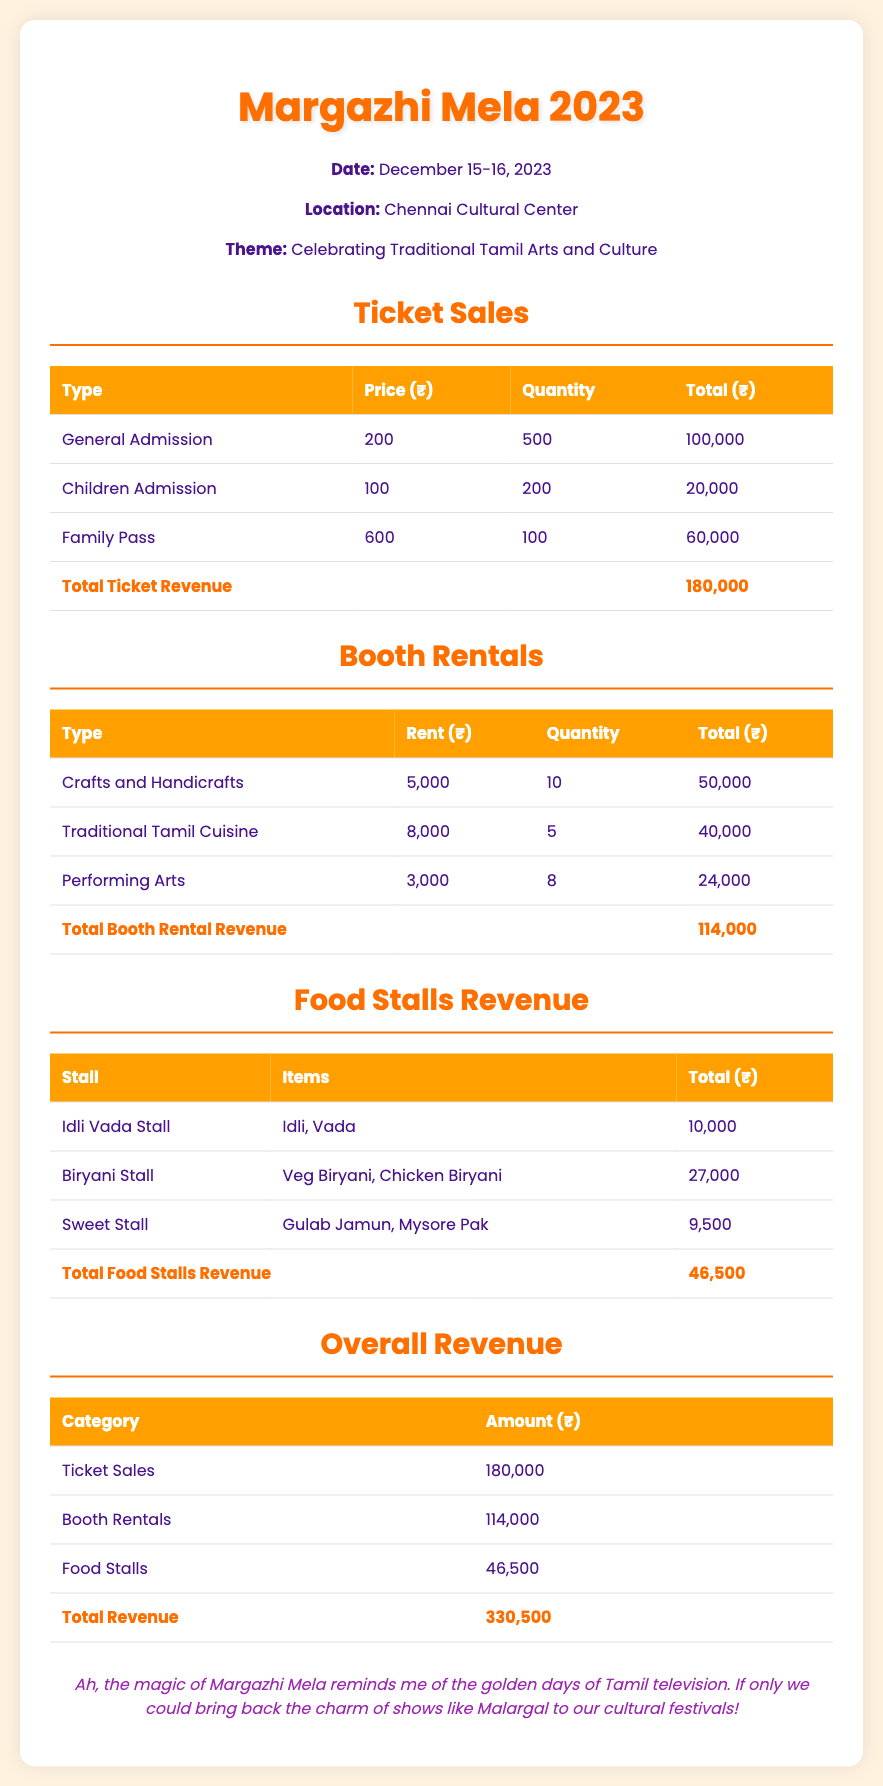What is the date of the event? The event is scheduled for December 15-16, 2023.
Answer: December 15-16, 2023 What is the total ticket revenue? The total revenue from ticket sales is specified in a dedicated section of the document.
Answer: 180,000 How many Family Passes were sold? The document details the quantity of Family Passes sold alongside ticket types and their prices.
Answer: 100 What is the rent for Traditional Tamil Cuisine booths? The document lists the rent for each type of booth, including Traditional Tamil Cuisine.
Answer: 8,000 What is the total revenue from food stalls? The total food stalls revenue is provided at the end of the food stalls section.
Answer: 46,500 What is the overall total revenue? The document provides a summary of total revenue based on all income sources in one section.
Answer: 330,500 What is the rent for Crafts and Handicrafts booths? The document outlines the rent for Crafts and Handicrafts within the booth rentals section.
Answer: 5,000 How many general admission tickets were sold? The quantity of general admission tickets sold is detailed in the ticket sales table.
Answer: 500 